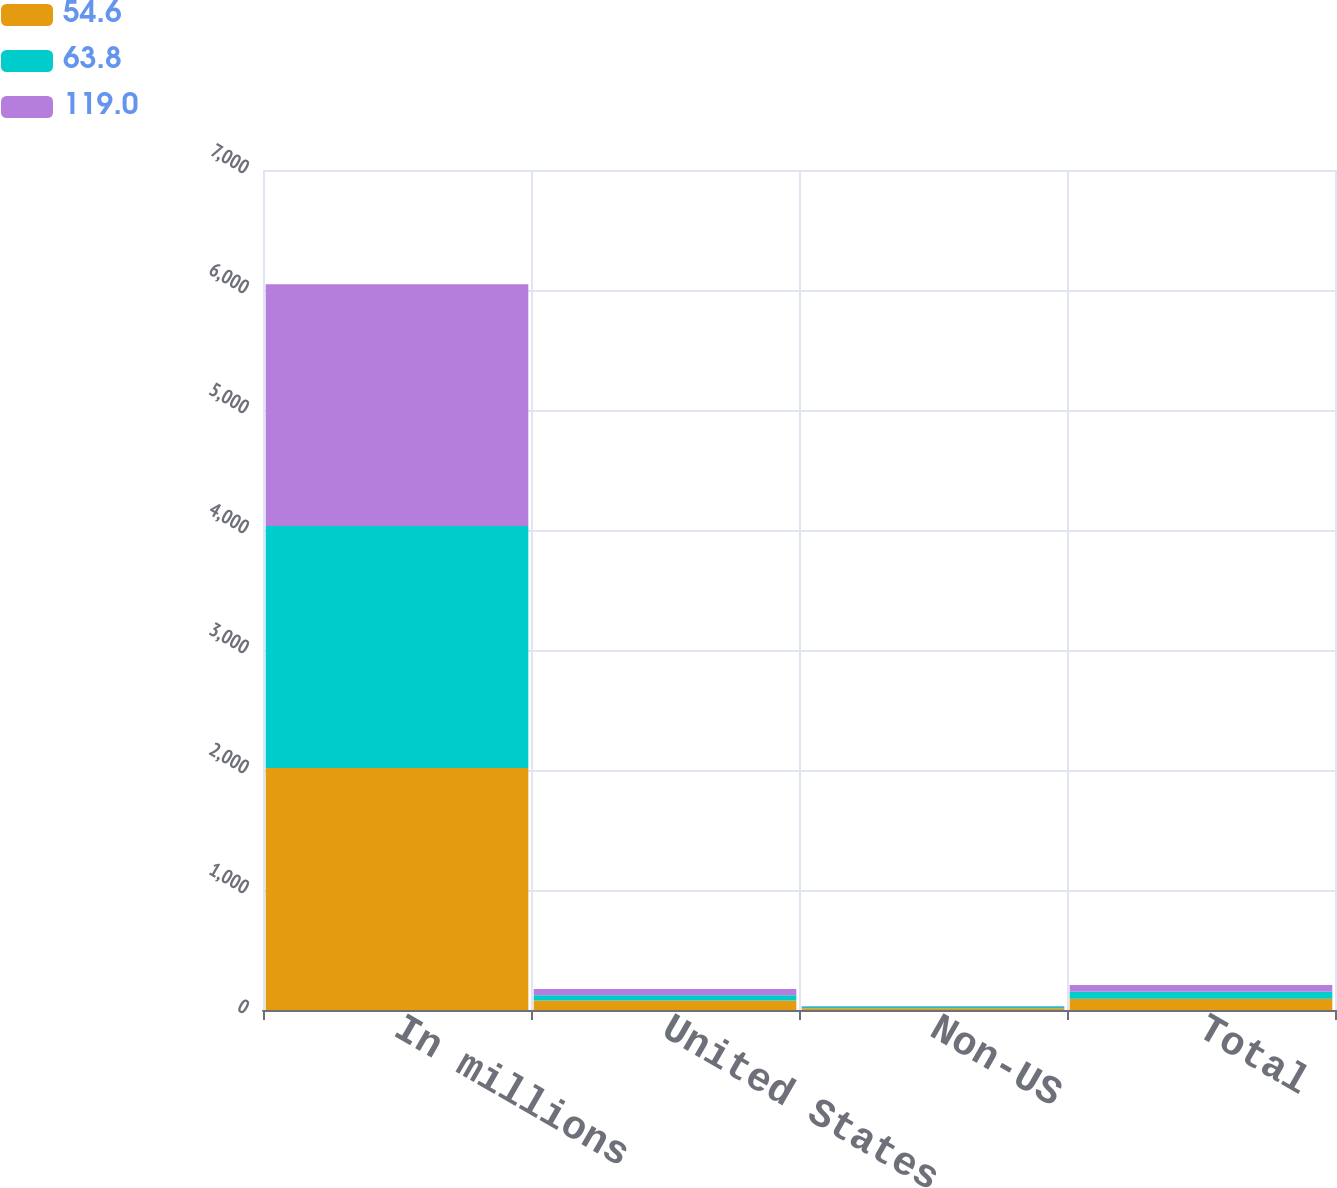Convert chart. <chart><loc_0><loc_0><loc_500><loc_500><stacked_bar_chart><ecel><fcel>In millions<fcel>United States<fcel>Non-US<fcel>Total<nl><fcel>54.6<fcel>2017<fcel>78.8<fcel>15<fcel>93.8<nl><fcel>63.8<fcel>2016<fcel>43.8<fcel>13.8<fcel>57.6<nl><fcel>119<fcel>2015<fcel>53.4<fcel>3.5<fcel>56.9<nl></chart> 